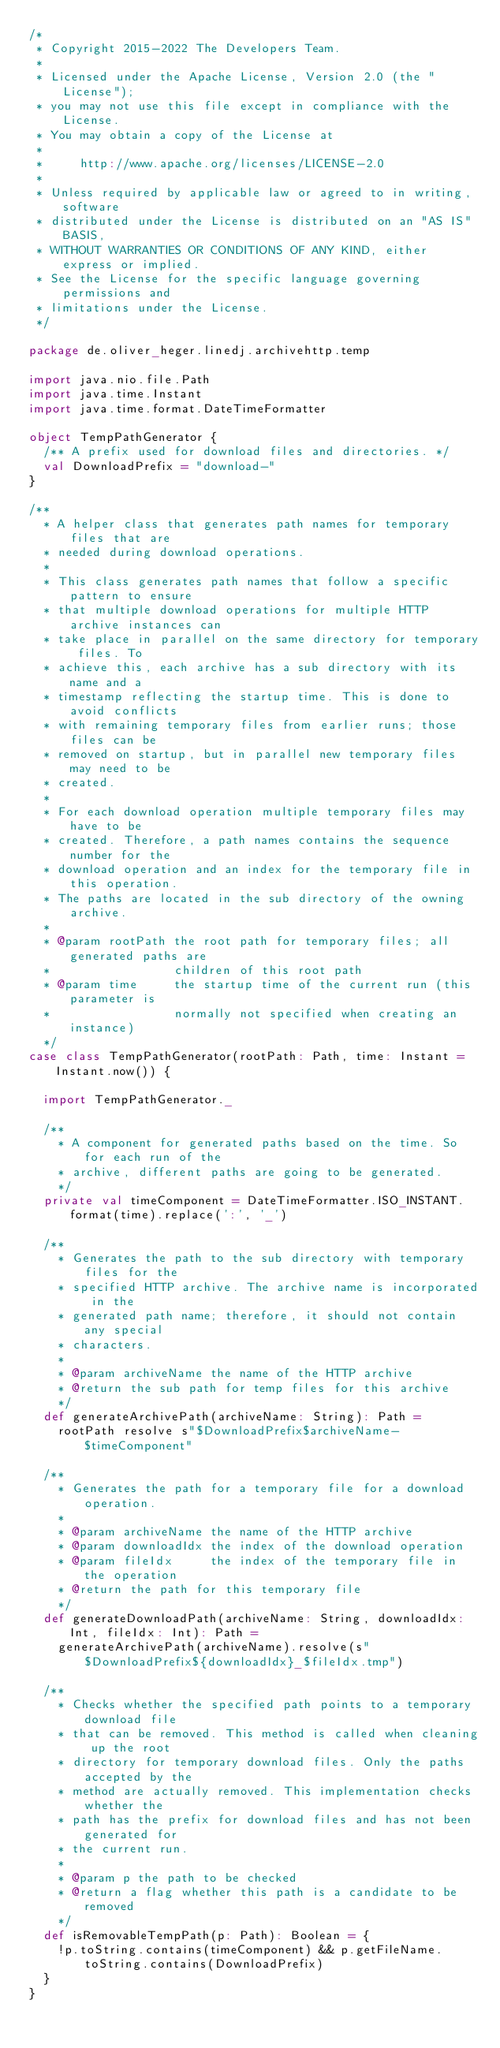<code> <loc_0><loc_0><loc_500><loc_500><_Scala_>/*
 * Copyright 2015-2022 The Developers Team.
 *
 * Licensed under the Apache License, Version 2.0 (the "License");
 * you may not use this file except in compliance with the License.
 * You may obtain a copy of the License at
 *
 *     http://www.apache.org/licenses/LICENSE-2.0
 *
 * Unless required by applicable law or agreed to in writing, software
 * distributed under the License is distributed on an "AS IS" BASIS,
 * WITHOUT WARRANTIES OR CONDITIONS OF ANY KIND, either express or implied.
 * See the License for the specific language governing permissions and
 * limitations under the License.
 */

package de.oliver_heger.linedj.archivehttp.temp

import java.nio.file.Path
import java.time.Instant
import java.time.format.DateTimeFormatter

object TempPathGenerator {
  /** A prefix used for download files and directories. */
  val DownloadPrefix = "download-"
}

/**
  * A helper class that generates path names for temporary files that are
  * needed during download operations.
  *
  * This class generates path names that follow a specific pattern to ensure
  * that multiple download operations for multiple HTTP archive instances can
  * take place in parallel on the same directory for temporary files. To
  * achieve this, each archive has a sub directory with its name and a
  * timestamp reflecting the startup time. This is done to avoid conflicts
  * with remaining temporary files from earlier runs; those files can be
  * removed on startup, but in parallel new temporary files may need to be
  * created.
  *
  * For each download operation multiple temporary files may have to be
  * created. Therefore, a path names contains the sequence number for the
  * download operation and an index for the temporary file in this operation.
  * The paths are located in the sub directory of the owning archive.
  *
  * @param rootPath the root path for temporary files; all generated paths are
  *                 children of this root path
  * @param time     the startup time of the current run (this parameter is
  *                 normally not specified when creating an instance)
  */
case class TempPathGenerator(rootPath: Path, time: Instant = Instant.now()) {

  import TempPathGenerator._

  /**
    * A component for generated paths based on the time. So for each run of the
    * archive, different paths are going to be generated.
    */
  private val timeComponent = DateTimeFormatter.ISO_INSTANT.format(time).replace(':', '_')

  /**
    * Generates the path to the sub directory with temporary files for the
    * specified HTTP archive. The archive name is incorporated in the
    * generated path name; therefore, it should not contain any special
    * characters.
    *
    * @param archiveName the name of the HTTP archive
    * @return the sub path for temp files for this archive
    */
  def generateArchivePath(archiveName: String): Path =
    rootPath resolve s"$DownloadPrefix$archiveName-$timeComponent"

  /**
    * Generates the path for a temporary file for a download operation.
    *
    * @param archiveName the name of the HTTP archive
    * @param downloadIdx the index of the download operation
    * @param fileIdx     the index of the temporary file in the operation
    * @return the path for this temporary file
    */
  def generateDownloadPath(archiveName: String, downloadIdx: Int, fileIdx: Int): Path =
    generateArchivePath(archiveName).resolve(s"$DownloadPrefix${downloadIdx}_$fileIdx.tmp")

  /**
    * Checks whether the specified path points to a temporary download file
    * that can be removed. This method is called when cleaning up the root
    * directory for temporary download files. Only the paths accepted by the
    * method are actually removed. This implementation checks whether the
    * path has the prefix for download files and has not been generated for
    * the current run.
    *
    * @param p the path to be checked
    * @return a flag whether this path is a candidate to be removed
    */
  def isRemovableTempPath(p: Path): Boolean = {
    !p.toString.contains(timeComponent) && p.getFileName.toString.contains(DownloadPrefix)
  }
}
</code> 